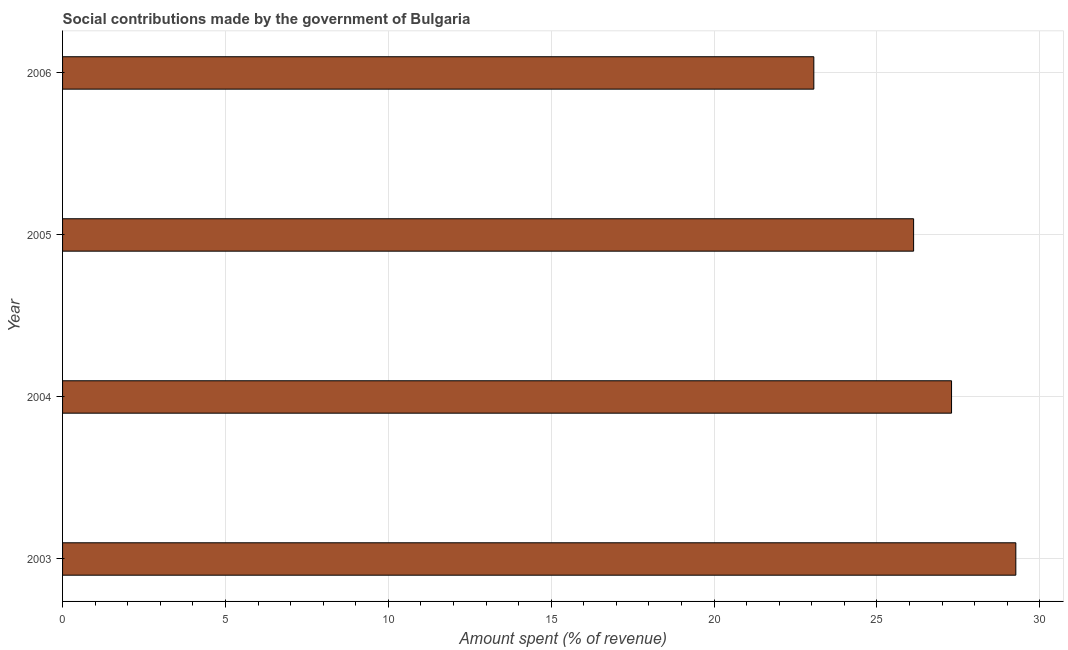Does the graph contain any zero values?
Provide a succinct answer. No. What is the title of the graph?
Ensure brevity in your answer.  Social contributions made by the government of Bulgaria. What is the label or title of the X-axis?
Provide a succinct answer. Amount spent (% of revenue). What is the label or title of the Y-axis?
Ensure brevity in your answer.  Year. What is the amount spent in making social contributions in 2006?
Your response must be concise. 23.06. Across all years, what is the maximum amount spent in making social contributions?
Provide a short and direct response. 29.27. Across all years, what is the minimum amount spent in making social contributions?
Give a very brief answer. 23.06. What is the sum of the amount spent in making social contributions?
Offer a very short reply. 105.75. What is the difference between the amount spent in making social contributions in 2005 and 2006?
Your answer should be very brief. 3.06. What is the average amount spent in making social contributions per year?
Offer a terse response. 26.44. What is the median amount spent in making social contributions?
Keep it short and to the point. 26.71. In how many years, is the amount spent in making social contributions greater than 9 %?
Your response must be concise. 4. What is the ratio of the amount spent in making social contributions in 2003 to that in 2005?
Offer a terse response. 1.12. Is the amount spent in making social contributions in 2005 less than that in 2006?
Ensure brevity in your answer.  No. Is the difference between the amount spent in making social contributions in 2003 and 2005 greater than the difference between any two years?
Offer a very short reply. No. What is the difference between the highest and the second highest amount spent in making social contributions?
Keep it short and to the point. 1.97. Is the sum of the amount spent in making social contributions in 2004 and 2006 greater than the maximum amount spent in making social contributions across all years?
Offer a very short reply. Yes. What is the difference between the highest and the lowest amount spent in making social contributions?
Your answer should be very brief. 6.2. What is the Amount spent (% of revenue) of 2003?
Your response must be concise. 29.27. What is the Amount spent (% of revenue) in 2004?
Keep it short and to the point. 27.29. What is the Amount spent (% of revenue) of 2005?
Your response must be concise. 26.13. What is the Amount spent (% of revenue) of 2006?
Your answer should be very brief. 23.06. What is the difference between the Amount spent (% of revenue) in 2003 and 2004?
Make the answer very short. 1.97. What is the difference between the Amount spent (% of revenue) in 2003 and 2005?
Provide a succinct answer. 3.14. What is the difference between the Amount spent (% of revenue) in 2003 and 2006?
Your response must be concise. 6.2. What is the difference between the Amount spent (% of revenue) in 2004 and 2005?
Ensure brevity in your answer.  1.16. What is the difference between the Amount spent (% of revenue) in 2004 and 2006?
Provide a short and direct response. 4.23. What is the difference between the Amount spent (% of revenue) in 2005 and 2006?
Make the answer very short. 3.06. What is the ratio of the Amount spent (% of revenue) in 2003 to that in 2004?
Give a very brief answer. 1.07. What is the ratio of the Amount spent (% of revenue) in 2003 to that in 2005?
Ensure brevity in your answer.  1.12. What is the ratio of the Amount spent (% of revenue) in 2003 to that in 2006?
Offer a very short reply. 1.27. What is the ratio of the Amount spent (% of revenue) in 2004 to that in 2005?
Provide a succinct answer. 1.04. What is the ratio of the Amount spent (% of revenue) in 2004 to that in 2006?
Your answer should be compact. 1.18. What is the ratio of the Amount spent (% of revenue) in 2005 to that in 2006?
Provide a succinct answer. 1.13. 